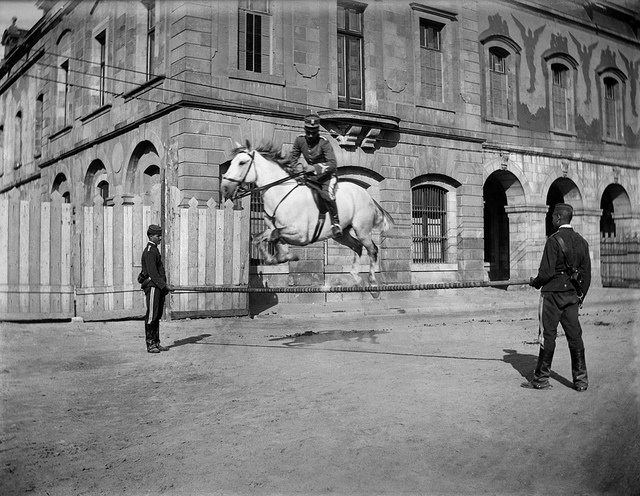Describe the objects in this image and their specific colors. I can see horse in gray, lightgray, darkgray, and black tones, people in gray, black, darkgray, and lightgray tones, people in gray, black, darkgray, and lightgray tones, and people in gray, black, darkgray, and lightgray tones in this image. 